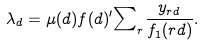Convert formula to latex. <formula><loc_0><loc_0><loc_500><loc_500>\lambda _ { d } = \mu ( d ) f ( d ) { ^ { \prime } } { \sum } _ { r } \frac { y _ { r d } } { f _ { 1 } ( r d ) } .</formula> 